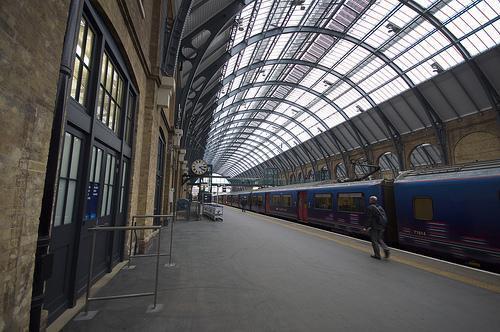How many people are there?
Give a very brief answer. 2. 